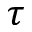<formula> <loc_0><loc_0><loc_500><loc_500>\tau</formula> 